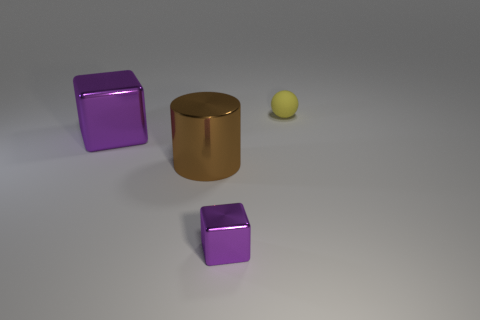Is the color of the big block the same as the cube that is in front of the big purple metallic cube?
Your answer should be compact. Yes. What size is the other shiny cube that is the same color as the large cube?
Provide a short and direct response. Small. Is the color of the tiny block the same as the large cube?
Your response must be concise. Yes. Is the brown object the same size as the yellow sphere?
Your answer should be very brief. No. There is a tiny object that is left of the rubber thing; does it have the same color as the large block?
Make the answer very short. Yes. There is a tiny thing to the left of the small object that is behind the small object that is left of the yellow rubber ball; what is its shape?
Your response must be concise. Cube. There is a object that is the same color as the tiny shiny cube; what is it made of?
Your answer should be compact. Metal. How many small purple objects have the same shape as the large purple object?
Provide a short and direct response. 1. Is the color of the metal cube behind the big metal cylinder the same as the shiny cube in front of the large purple object?
Offer a very short reply. Yes. There is a block that is the same size as the sphere; what material is it?
Offer a very short reply. Metal. 